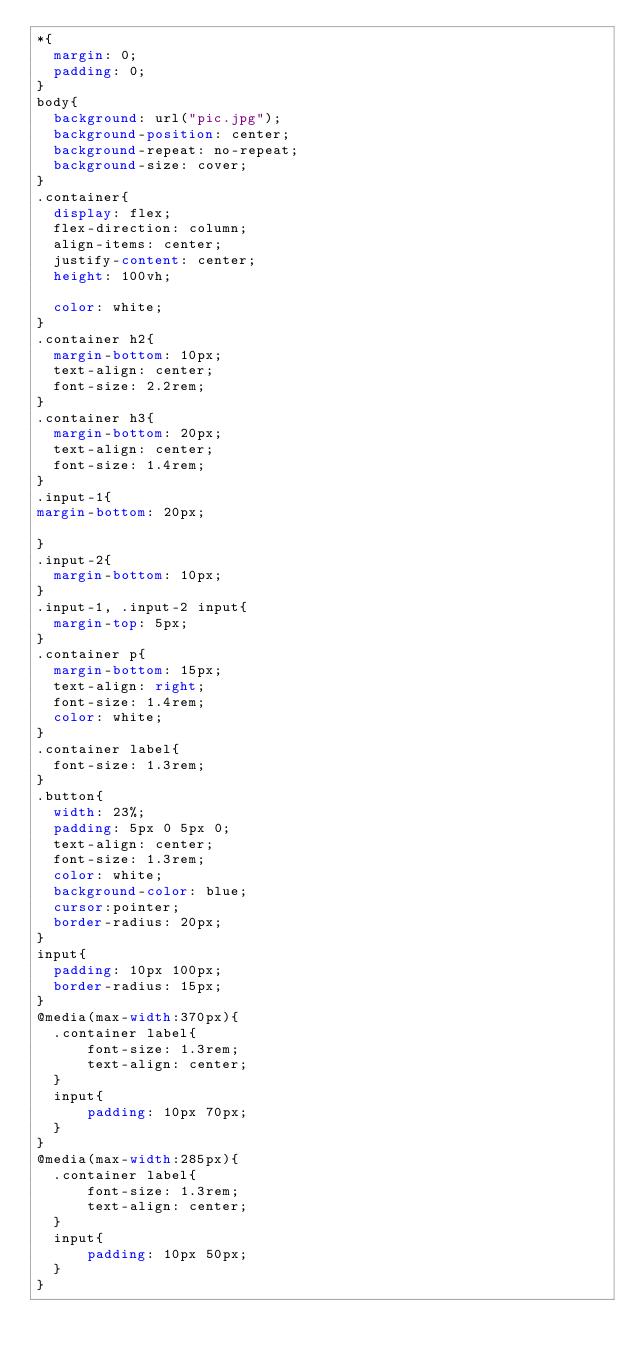<code> <loc_0><loc_0><loc_500><loc_500><_CSS_>*{
  margin: 0;
  padding: 0;
}
body{
  background: url("pic.jpg");
  background-position: center;
  background-repeat: no-repeat;
  background-size: cover;
}
.container{
  display: flex;
  flex-direction: column;
  align-items: center;
  justify-content: center;
  height: 100vh;
 
  color: white;
}
.container h2{
  margin-bottom: 10px;
  text-align: center;
  font-size: 2.2rem;
}
.container h3{
  margin-bottom: 20px;
  text-align: center;
  font-size: 1.4rem;
}
.input-1{
margin-bottom: 20px;

}
.input-2{
  margin-bottom: 10px;
}
.input-1, .input-2 input{
  margin-top: 5px;
}
.container p{
  margin-bottom: 15px;
  text-align: right;
  font-size: 1.4rem;
  color: white;
}
.container label{
  font-size: 1.3rem;
}
.button{
  width: 23%;
  padding: 5px 0 5px 0;
  text-align: center;
  font-size: 1.3rem;
  color: white;
  background-color: blue;
  cursor:pointer;
  border-radius: 20px;
}
input{
  padding: 10px 100px;
  border-radius: 15px;
}
@media(max-width:370px){
  .container label{
      font-size: 1.3rem;
      text-align: center;
  }
  input{
      padding: 10px 70px;
  }
}
@media(max-width:285px){
  .container label{
      font-size: 1.3rem;
      text-align: center;
  }
  input{
      padding: 10px 50px;
  }
}</code> 